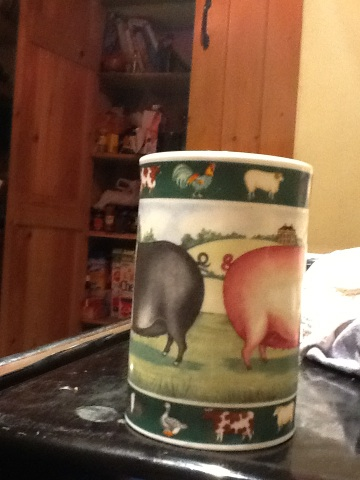What could be inside this cup? Inside the cup, there could be any number of things typically worthy of a cup! It might be filled with a warm beverage like tea or coffee, or perhaps it holds pencils and pens if used as an office accessory. Given the theme, it could even hold something fun and thematic like candies or small trinkets. What could inspire someone to design such a cup? Someone could be inspired to design such a cup by their love for countryside life and farm animals. It could also come from a desire to create household items that evoke warmth, nostalgia, and a connection to nature. The designer might have grown up on a farm or simply appreciate the simplicity and tranquility that such scenes represent. 